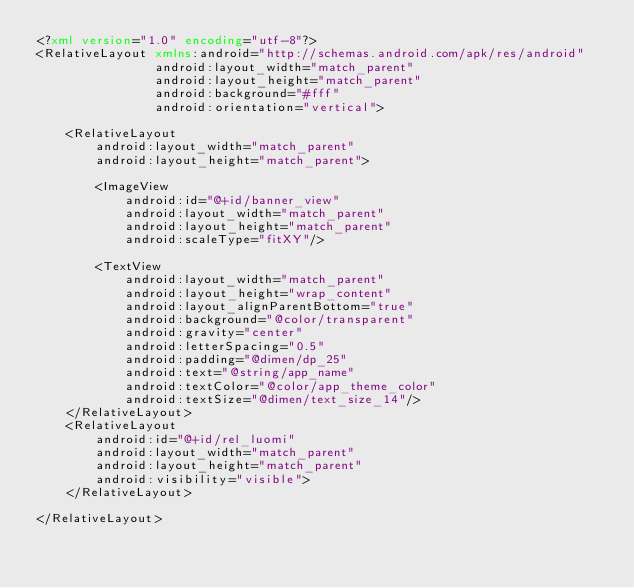Convert code to text. <code><loc_0><loc_0><loc_500><loc_500><_XML_><?xml version="1.0" encoding="utf-8"?>
<RelativeLayout xmlns:android="http://schemas.android.com/apk/res/android"
                android:layout_width="match_parent"
                android:layout_height="match_parent"
                android:background="#fff"
                android:orientation="vertical">

    <RelativeLayout
        android:layout_width="match_parent"
        android:layout_height="match_parent">

        <ImageView
            android:id="@+id/banner_view"
            android:layout_width="match_parent"
            android:layout_height="match_parent"
            android:scaleType="fitXY"/>

        <TextView
            android:layout_width="match_parent"
            android:layout_height="wrap_content"
            android:layout_alignParentBottom="true"
            android:background="@color/transparent"
            android:gravity="center"
            android:letterSpacing="0.5"
            android:padding="@dimen/dp_25"
            android:text="@string/app_name"
            android:textColor="@color/app_theme_color"
            android:textSize="@dimen/text_size_14"/>
    </RelativeLayout>
    <RelativeLayout
        android:id="@+id/rel_luomi"
        android:layout_width="match_parent"
        android:layout_height="match_parent"
        android:visibility="visible">
    </RelativeLayout>

</RelativeLayout></code> 